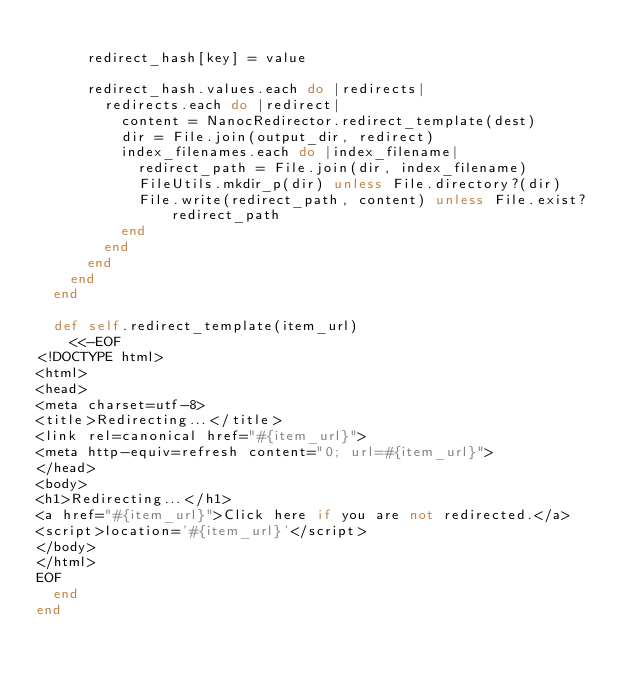Convert code to text. <code><loc_0><loc_0><loc_500><loc_500><_Ruby_>
      redirect_hash[key] = value

      redirect_hash.values.each do |redirects|
        redirects.each do |redirect|
          content = NanocRedirector.redirect_template(dest)
          dir = File.join(output_dir, redirect)
          index_filenames.each do |index_filename|
            redirect_path = File.join(dir, index_filename)
            FileUtils.mkdir_p(dir) unless File.directory?(dir)
            File.write(redirect_path, content) unless File.exist? redirect_path
          end
        end
      end
    end
  end

  def self.redirect_template(item_url)
    <<-EOF
<!DOCTYPE html>
<html>
<head>
<meta charset=utf-8>
<title>Redirecting...</title>
<link rel=canonical href="#{item_url}">
<meta http-equiv=refresh content="0; url=#{item_url}">
</head>
<body>
<h1>Redirecting...</h1>
<a href="#{item_url}">Click here if you are not redirected.</a>
<script>location='#{item_url}'</script>
</body>
</html>
EOF
  end
end
</code> 